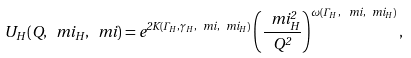<formula> <loc_0><loc_0><loc_500><loc_500>U _ { H } ( Q , \ m i _ { H } , \ m i ) = e ^ { 2 K ( \Gamma _ { H } , \gamma _ { H } , \ m i , \ m i _ { H } ) } \left ( \frac { \ m i _ { H } ^ { 2 } } { Q ^ { 2 } } \right ) ^ { \omega ( \Gamma _ { H } \, , \, \ m i , \ m i _ { H } ) } ,</formula> 